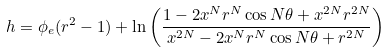<formula> <loc_0><loc_0><loc_500><loc_500>h = \phi _ { e } ( r ^ { 2 } - 1 ) + \ln \left ( \frac { 1 - 2 x ^ { N } r ^ { N } \cos N \theta + x ^ { 2 N } r ^ { 2 N } } { x ^ { 2 N } - 2 x ^ { N } r ^ { N } \cos N \theta + r ^ { 2 N } } \right )</formula> 